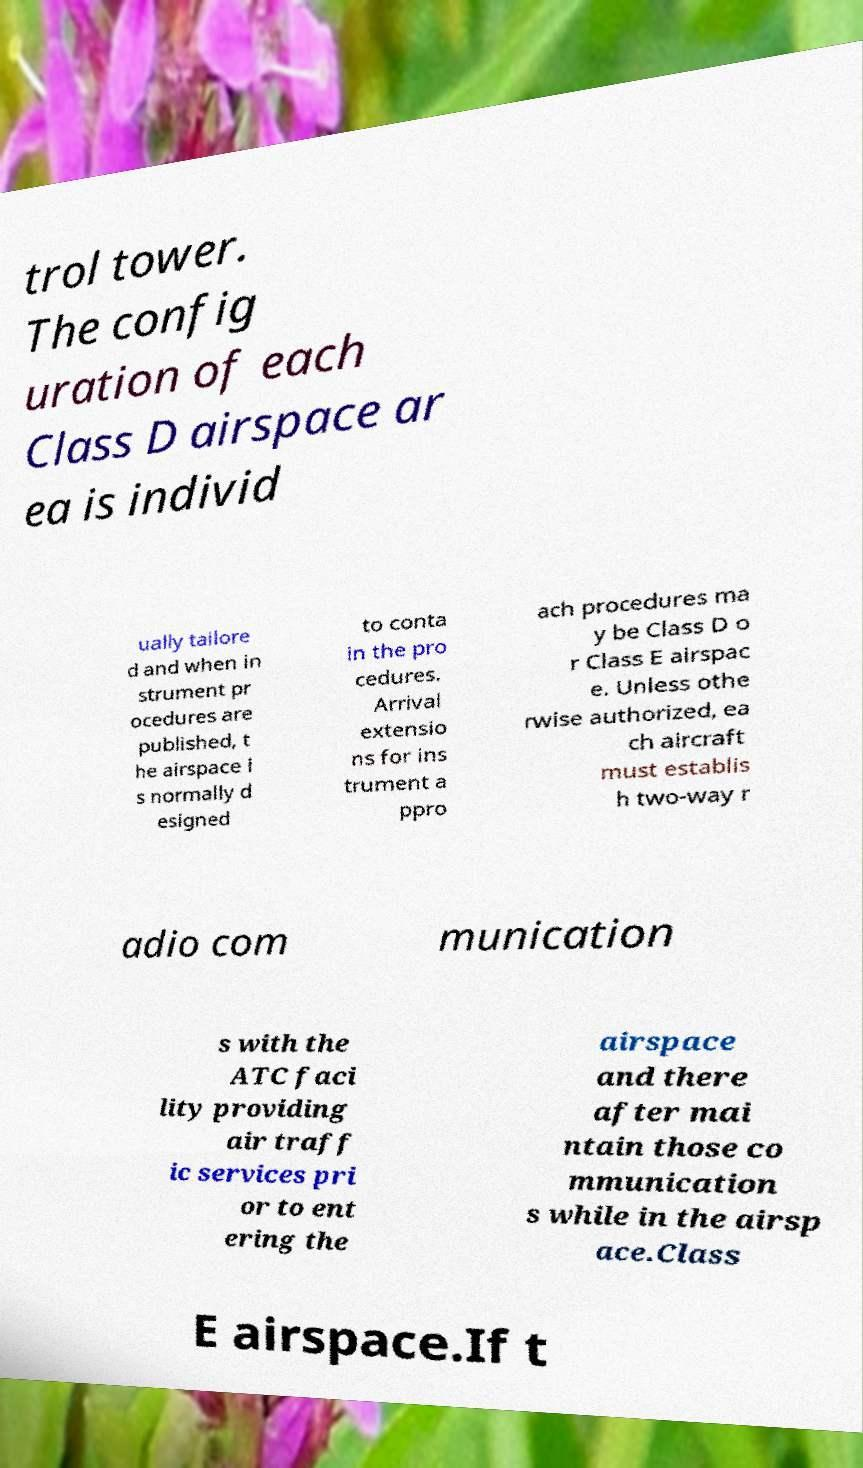Could you extract and type out the text from this image? trol tower. The config uration of each Class D airspace ar ea is individ ually tailore d and when in strument pr ocedures are published, t he airspace i s normally d esigned to conta in the pro cedures. Arrival extensio ns for ins trument a ppro ach procedures ma y be Class D o r Class E airspac e. Unless othe rwise authorized, ea ch aircraft must establis h two-way r adio com munication s with the ATC faci lity providing air traff ic services pri or to ent ering the airspace and there after mai ntain those co mmunication s while in the airsp ace.Class E airspace.If t 